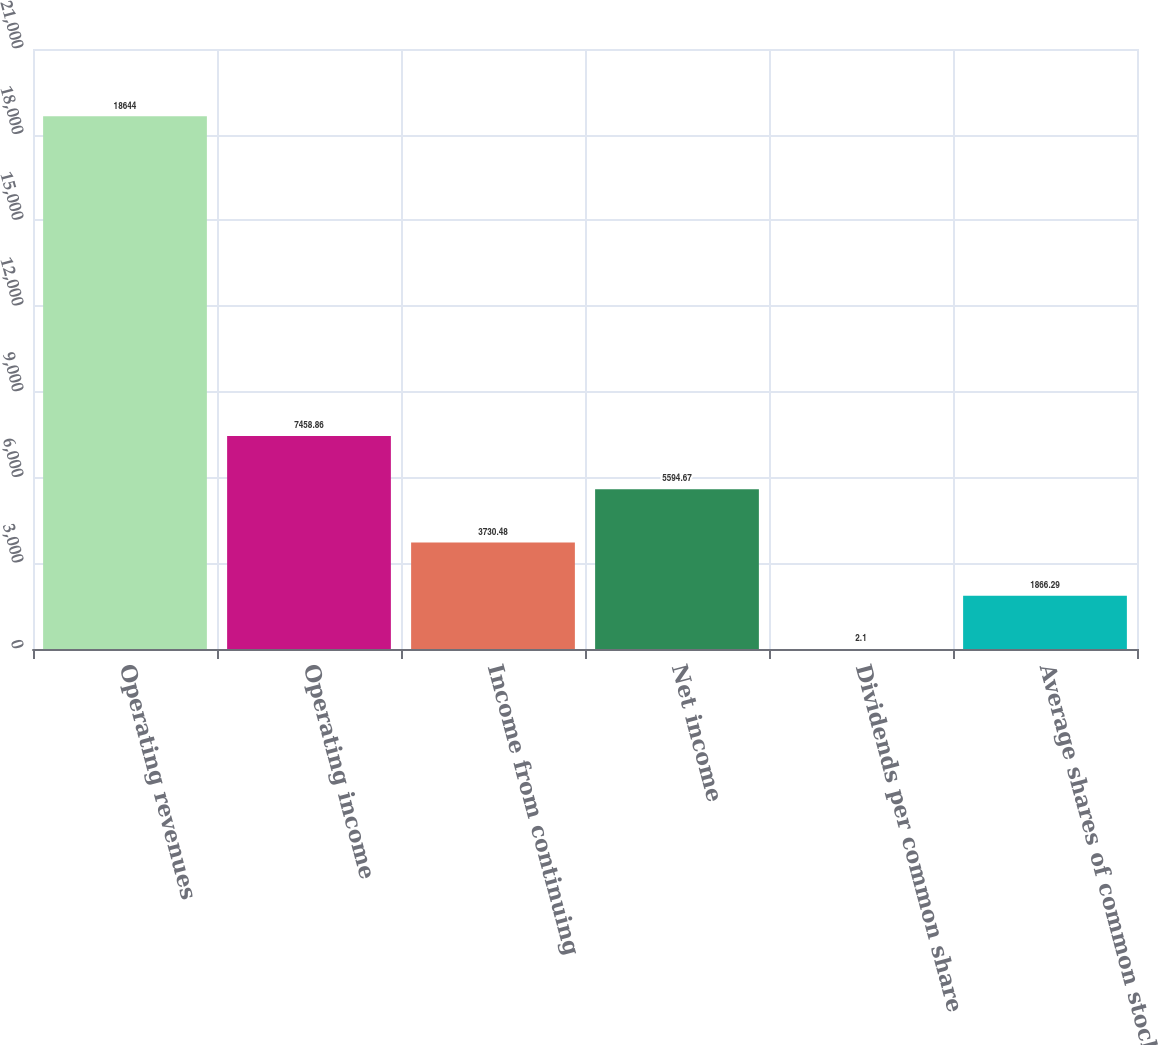Convert chart. <chart><loc_0><loc_0><loc_500><loc_500><bar_chart><fcel>Operating revenues<fcel>Operating income<fcel>Income from continuing<fcel>Net income<fcel>Dividends per common share<fcel>Average shares of common stock<nl><fcel>18644<fcel>7458.86<fcel>3730.48<fcel>5594.67<fcel>2.1<fcel>1866.29<nl></chart> 